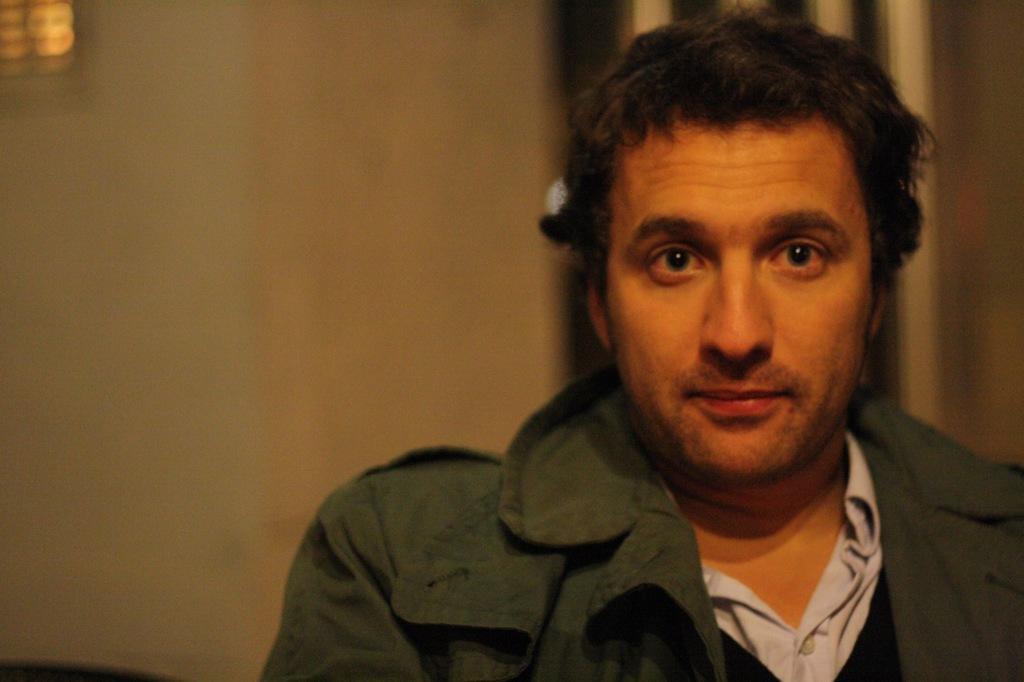Can you describe this image briefly? The man on the right corner of the picture wearing a white shirt and green jacket is looking at the camera. Behind him, we see a wall in white color. In the background, it is blurred in the background. This picture might be clicked inside the room. 